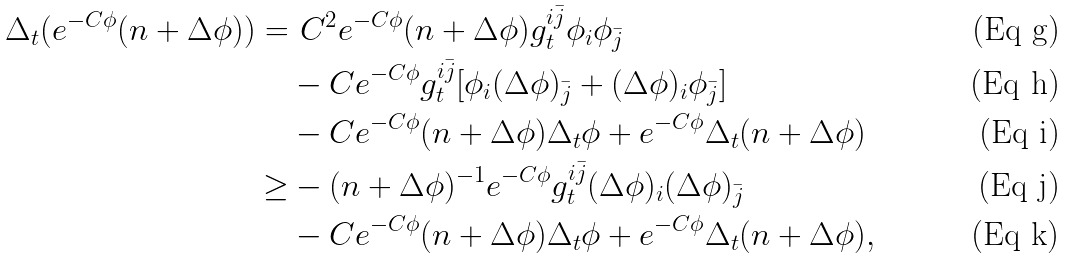Convert formula to latex. <formula><loc_0><loc_0><loc_500><loc_500>\Delta _ { t } ( e ^ { - C \phi } ( n + \Delta \phi ) ) = & \ C ^ { 2 } e ^ { - C \phi } ( n + \Delta \phi ) g ^ { i \bar { j } } _ { t } \phi _ { i } \phi _ { \bar { j } } \\ & - C e ^ { - C \phi } g ^ { i \bar { j } } _ { t } [ \phi _ { i } ( \Delta \phi ) _ { \bar { j } } + ( \Delta \phi ) _ { i } \phi _ { \bar { j } } ] \\ & - C e ^ { - C \phi } ( n + \Delta \phi ) \Delta _ { t } \phi + e ^ { - C \phi } \Delta _ { t } ( n + \Delta \phi ) \\ \geq & - ( n + \Delta \phi ) ^ { - 1 } e ^ { - C \phi } g ^ { i \bar { j } } _ { t } ( \Delta \phi ) _ { i } ( \Delta \phi ) _ { \bar { j } } \\ & - C e ^ { - C \phi } ( n + \Delta \phi ) \Delta _ { t } \phi + e ^ { - C \phi } \Delta _ { t } ( n + \Delta \phi ) ,</formula> 